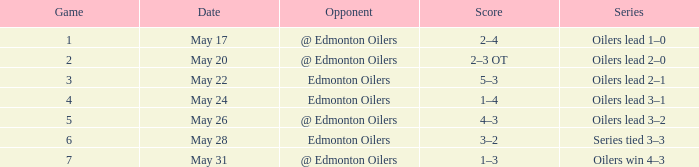Opponent of @ edmonton oilers, and a Game smaller than 7, and a Series of oilers lead 3–2 had what score? 4–3. 